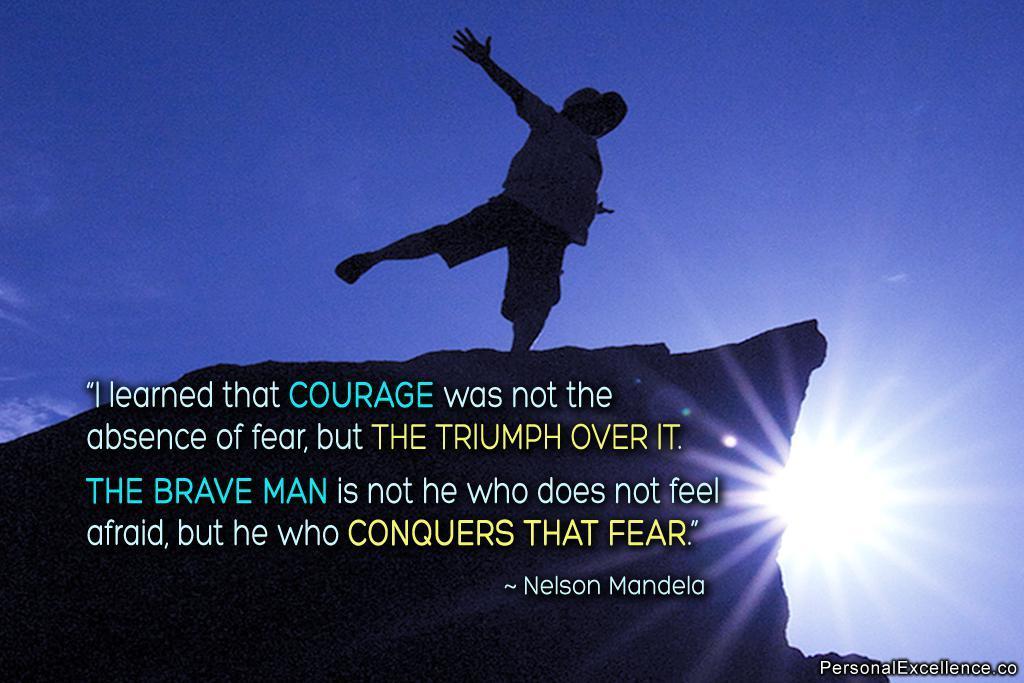In one or two sentences, can you explain what this image depicts? In this image we can see a person on the rock, also we can see the sun, and the sky, and there are some text on the image. 